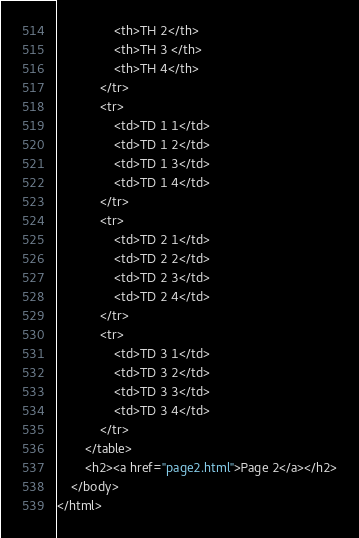<code> <loc_0><loc_0><loc_500><loc_500><_HTML_>                <th>TH 2</th>
                <th>TH 3 </th>
                <th>TH 4</th>
            </tr>
            <tr>
                <td>TD 1 1</td>
                <td>TD 1 2</td>
                <td>TD 1 3</td>
                <td>TD 1 4</td>
            </tr>
            <tr>
                <td>TD 2 1</td>
                <td>TD 2 2</td>
                <td>TD 2 3</td>
                <td>TD 2 4</td>
            </tr>
            <tr>
                <td>TD 3 1</td>
                <td>TD 3 2</td>
                <td>TD 3 3</td>
                <td>TD 3 4</td>
            </tr>
        </table>
        <h2><a href="page2.html">Page 2</a></h2>
    </body>
</html></code> 